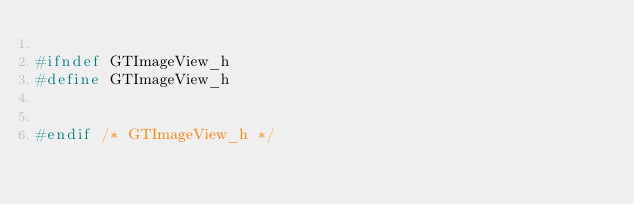<code> <loc_0><loc_0><loc_500><loc_500><_C_>
#ifndef GTImageView_h
#define GTImageView_h


#endif /* GTImageView_h */
</code> 